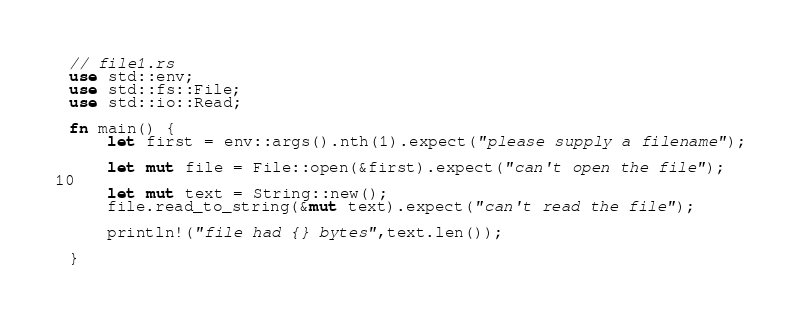<code> <loc_0><loc_0><loc_500><loc_500><_Rust_>// file1.rs
use std::env;
use std::fs::File;
use std::io::Read;

fn main() {
    let first = env::args().nth(1).expect("please supply a filename");

    let mut file = File::open(&first).expect("can't open the file");

    let mut text = String::new();
    file.read_to_string(&mut text).expect("can't read the file");

    println!("file had {} bytes",text.len());

}
</code> 